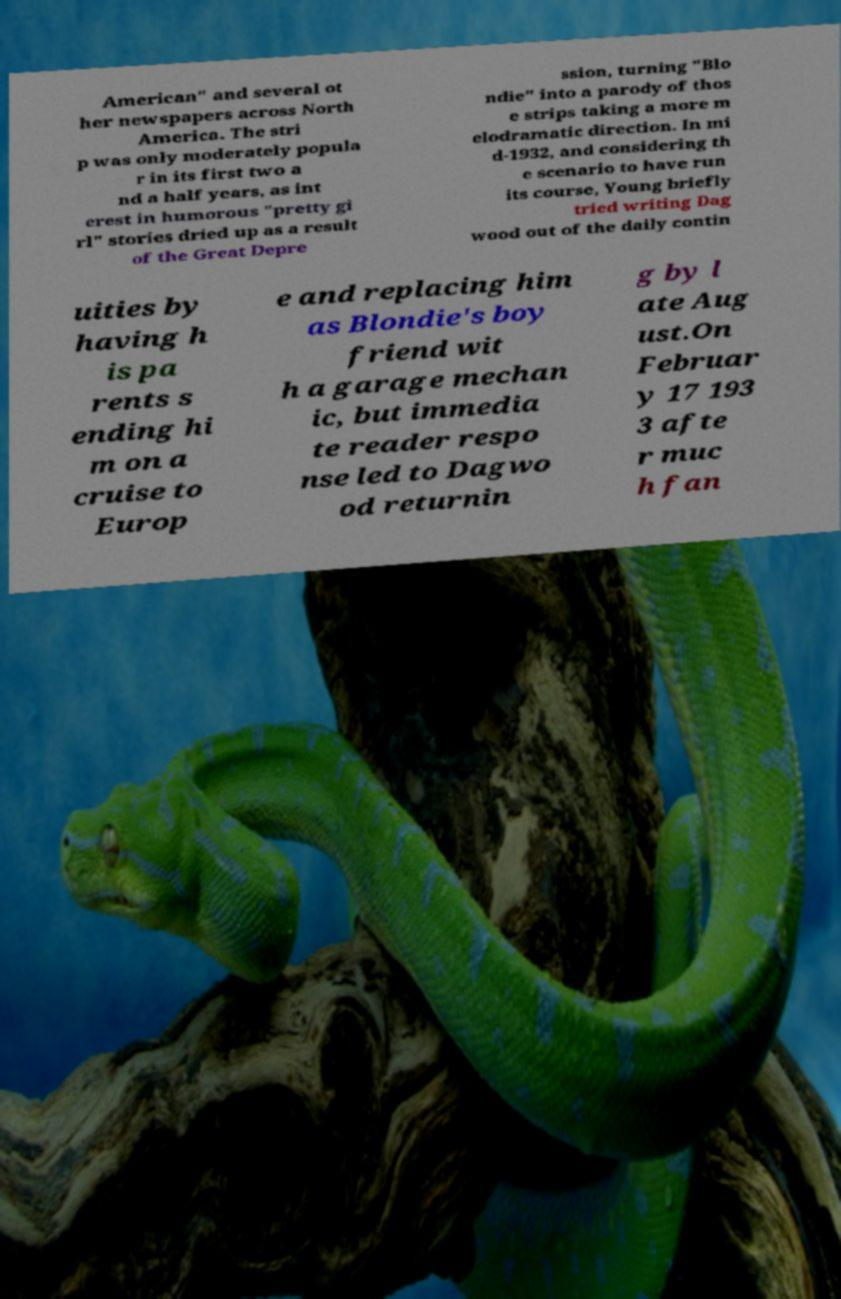I need the written content from this picture converted into text. Can you do that? American" and several ot her newspapers across North America. The stri p was only moderately popula r in its first two a nd a half years, as int erest in humorous "pretty gi rl" stories dried up as a result of the Great Depre ssion, turning "Blo ndie" into a parody of thos e strips taking a more m elodramatic direction. In mi d-1932, and considering th e scenario to have run its course, Young briefly tried writing Dag wood out of the daily contin uities by having h is pa rents s ending hi m on a cruise to Europ e and replacing him as Blondie's boy friend wit h a garage mechan ic, but immedia te reader respo nse led to Dagwo od returnin g by l ate Aug ust.On Februar y 17 193 3 afte r muc h fan 